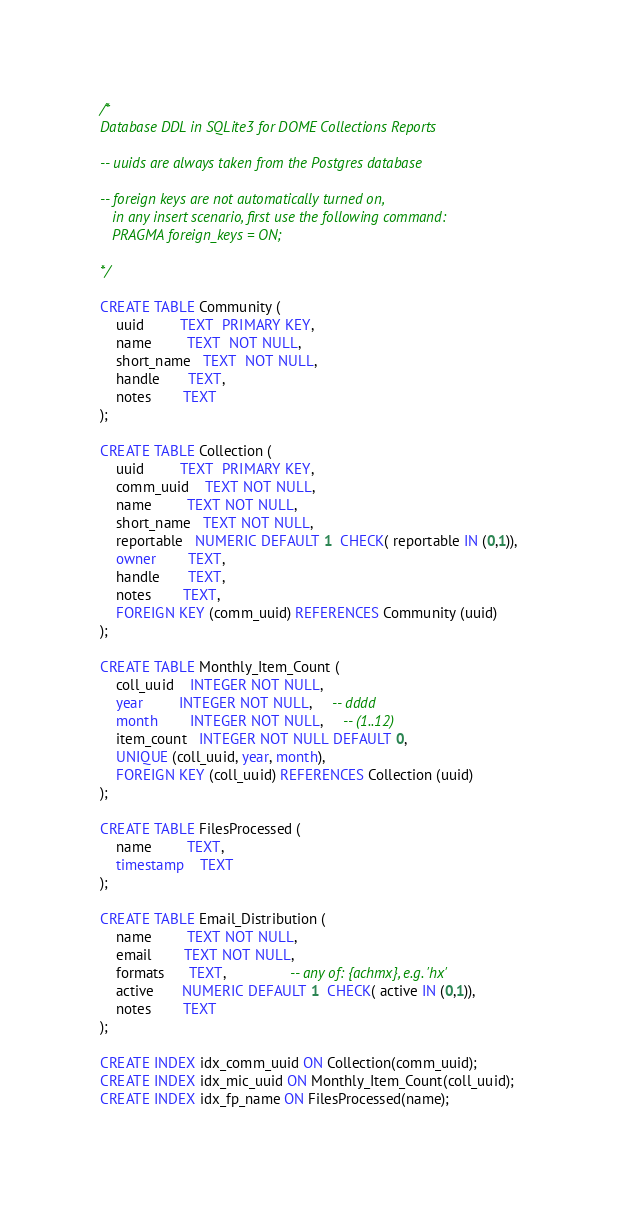Convert code to text. <code><loc_0><loc_0><loc_500><loc_500><_SQL_>/*
Database DDL in SQLite3 for DOME Collections Reports

-- uuids are always taken from the Postgres database

-- foreign keys are not automatically turned on,
   in any insert scenario, first use the following command:
   PRAGMA foreign_keys = ON;

*/

CREATE TABLE Community (
    uuid         TEXT  PRIMARY KEY,
    name         TEXT  NOT NULL,
    short_name   TEXT  NOT NULL,
    handle       TEXT,
    notes        TEXT
);

CREATE TABLE Collection (
    uuid         TEXT  PRIMARY KEY,
    comm_uuid    TEXT NOT NULL,
    name         TEXT NOT NULL,
    short_name   TEXT NOT NULL,
    reportable   NUMERIC DEFAULT 1  CHECK( reportable IN (0,1)),
    owner        TEXT,
    handle       TEXT,
    notes        TEXT,
    FOREIGN KEY (comm_uuid) REFERENCES Community (uuid)
);

CREATE TABLE Monthly_Item_Count (
    coll_uuid    INTEGER NOT NULL,
    year         INTEGER NOT NULL,     -- dddd
    month        INTEGER NOT NULL,     -- (1..12)
    item_count   INTEGER NOT NULL DEFAULT 0,
    UNIQUE (coll_uuid, year, month),
    FOREIGN KEY (coll_uuid) REFERENCES Collection (uuid)
);

CREATE TABLE FilesProcessed (
    name         TEXT,
    timestamp    TEXT
);

CREATE TABLE Email_Distribution (
    name         TEXT NOT NULL,
    email        TEXT NOT NULL,
    formats      TEXT,                -- any of: {achmx}, e.g. 'hx'
    active       NUMERIC DEFAULT 1  CHECK( active IN (0,1)),
    notes        TEXT
); 

CREATE INDEX idx_comm_uuid ON Collection(comm_uuid);
CREATE INDEX idx_mic_uuid ON Monthly_Item_Count(coll_uuid);
CREATE INDEX idx_fp_name ON FilesProcessed(name);
</code> 